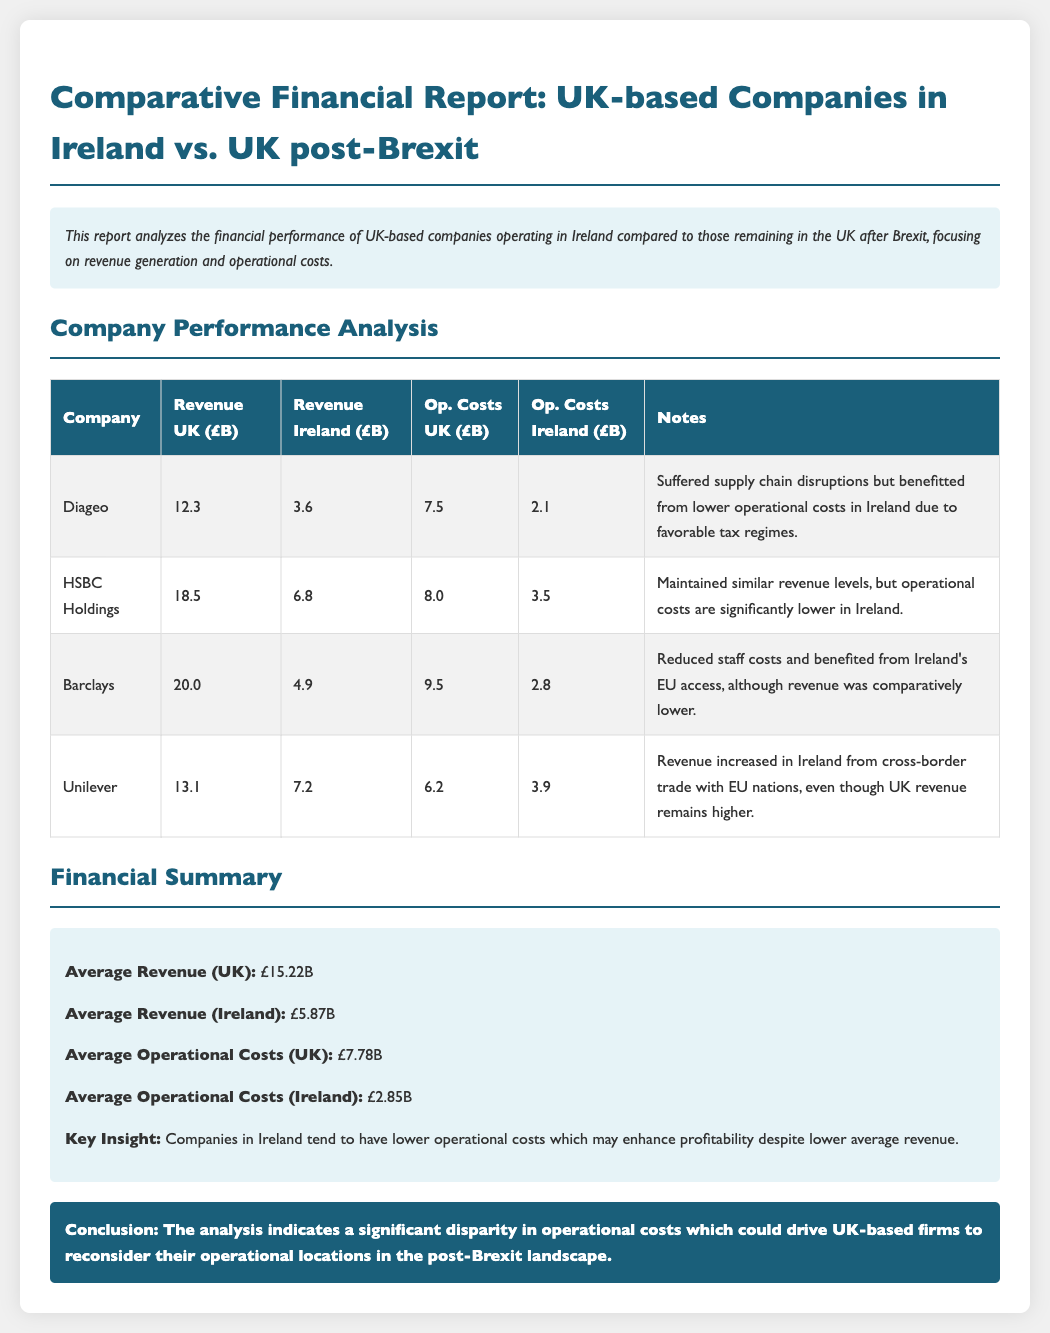what is the total revenue for Diageo in the UK? The total revenue for Diageo in the UK is given as £12.3 billion.
Answer: £12.3B what are the operational costs for Barclays in Ireland? The operational costs for Barclays in Ireland are listed as £2.8 billion.
Answer: £2.8B which company has the highest average revenue in the UK? The company with the highest average revenue in the UK is Barclays, with £20.0 billion.
Answer: Barclays what is the average operational cost for companies in Ireland? The average operational cost for companies in Ireland is calculated from the data, given as £2.85 billion.
Answer: £2.85B how much did Unilever earn from revenue in Ireland? Unilever's revenue in Ireland amounts to £7.2 billion.
Answer: £7.2B which company has the lowest revenue in Ireland? The company with the lowest revenue in Ireland is Barclays, which earned £4.9 billion.
Answer: Barclays what insight is provided regarding companies in Ireland? The report highlights that companies in Ireland tend to have lower operational costs which may enhance profitability.
Answer: Lower operational costs what is the average revenue for UK-based companies listed in the report? The average revenue for UK-based companies is provided as £15.22 billion.
Answer: £15.22B which company maintained similar revenue levels but had lower operational costs in Ireland? HSBC Holdings maintained similar revenue levels but had significantly lower operational costs in Ireland.
Answer: HSBC Holdings 